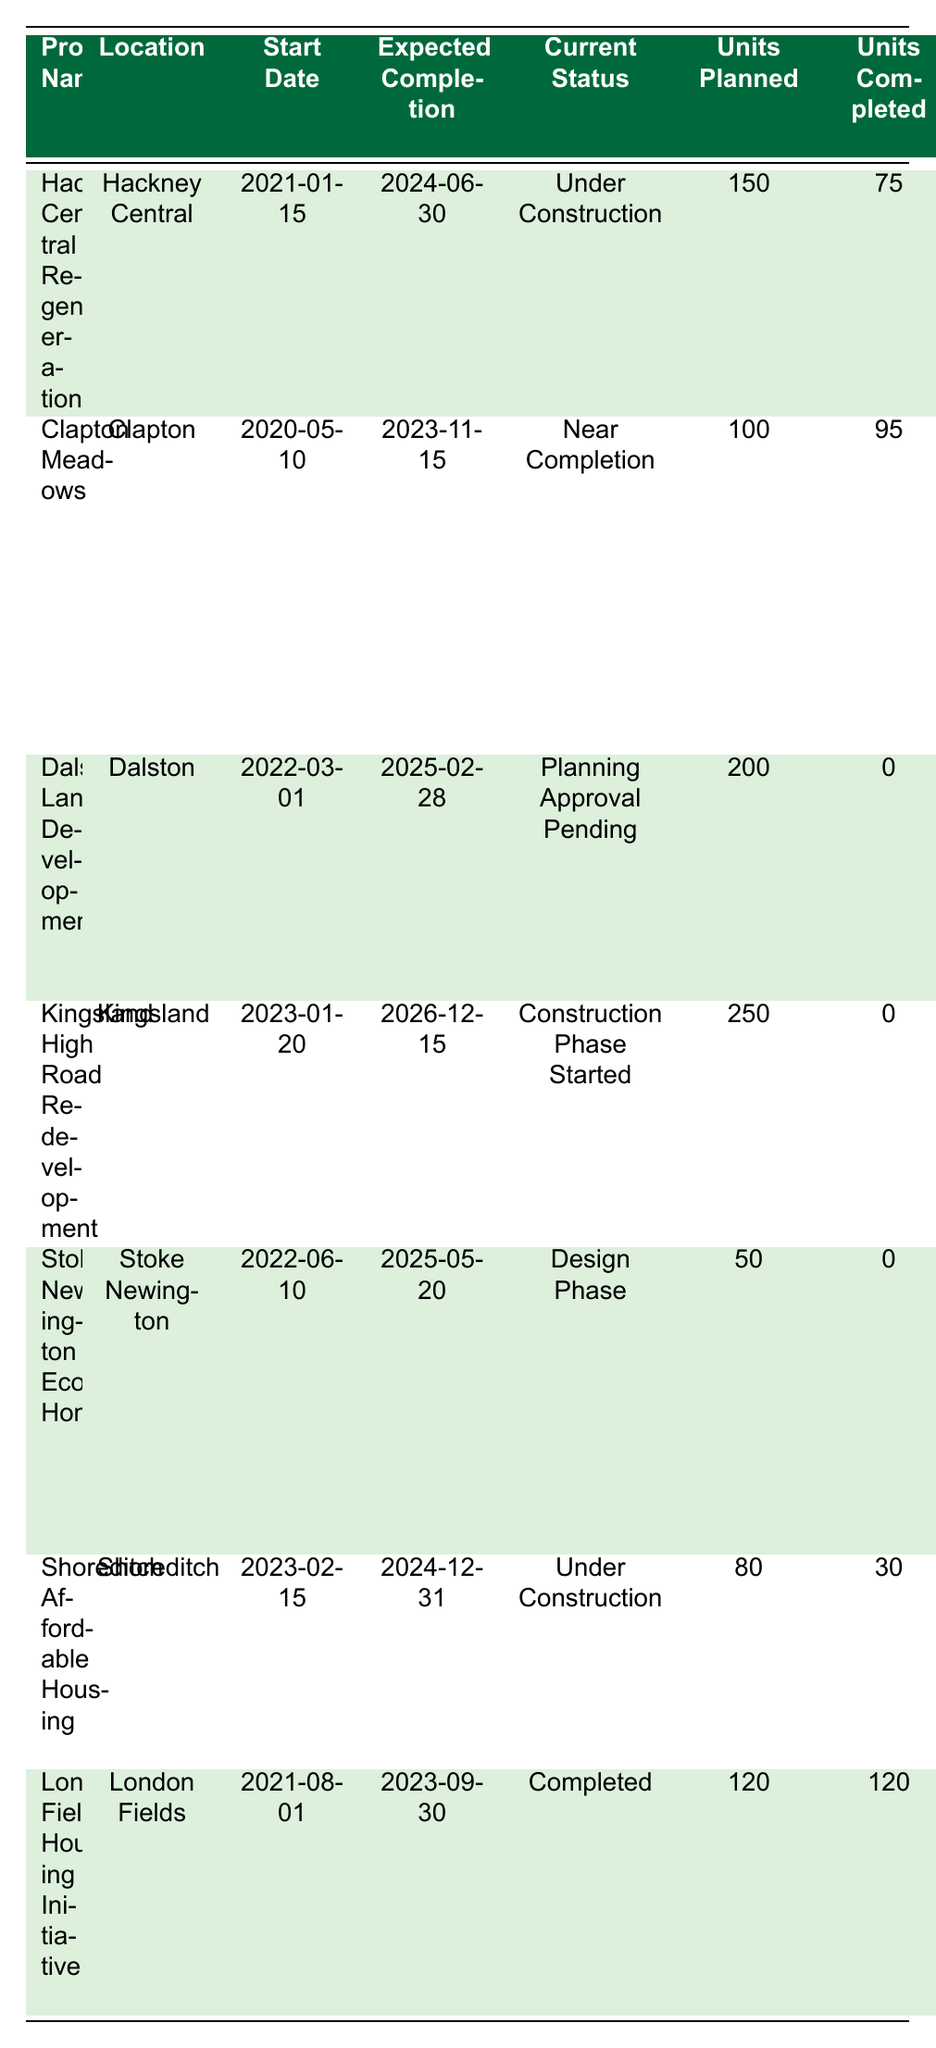What is the current status of the Clapton Meadows project? The current status of Clapton Meadows is listed in the table as "Near Completion."
Answer: Near Completion How many units are planned for the Hackney Central Regeneration project? The table indicates that the Hackney Central Regeneration project has 150 units planned.
Answer: 150 Which project has the highest percentage of affordable housing? By examining the percentages in the table, the Shoreditch Affordable Housing project has the highest affordable housing percentage of 60%.
Answer: 60% How many units are currently completed for the London Fields Housing Initiative? The table shows that 120 units are completed for the London Fields Housing Initiative.
Answer: 120 Is the Dalston Lane Development project currently under construction? The table states that the Dalston Lane Development is "Planning Approval Pending," thus it is not under construction.
Answer: No What is the difference between the total units planned and total units completed for the Kingsland High Road Redevelopment? The Kingsland High Road Redevelopment has 250 units planned and 0 units completed; the difference is 250 - 0 = 250.
Answer: 250 How many projects currently have a completion status of "Under Construction"? The table shows that there are two projects with "Under Construction" status: Hackney Central Regeneration and Shoreditch Affordable Housing.
Answer: 2 What is the average affordable housing percentage across all projects listed? The total affordable housing percentages are: 40%, 30%, 25%, 35%, 50%, 60%, 55%, which sums up to 295. Since there are 7 projects, the average is 295/7 ≈ 42.14%.
Answer: 42.14% Which project was started most recently? The Kingsland High Road Redevelopment project started on 2023-01-20, which is the most recent start date compared to others in the table.
Answer: Kingsland High Road Redevelopment What will be the expected completion date of the Stoke Newington Eco Homes project? The table indicates the expected completion date for Stoke Newington Eco Homes is 2025-05-20.
Answer: 2025-05-20 